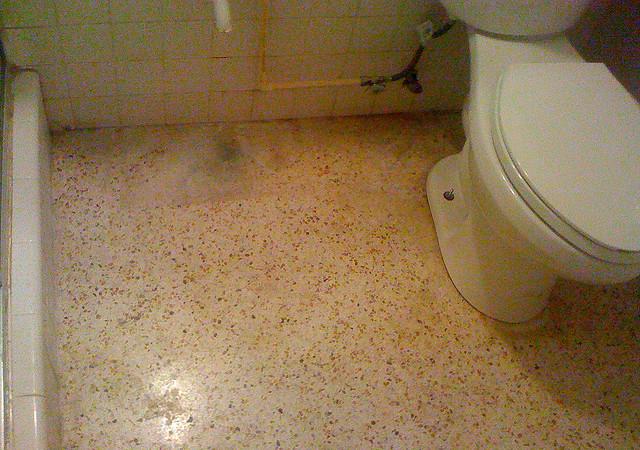Is the seat raised?
Write a very short answer. No. Is there something wrong with the pipes?
Keep it brief. Yes. Is this a public or private bathroom?
Give a very brief answer. Private. 